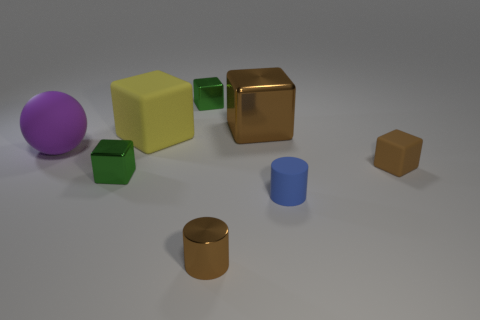Subtract all yellow blocks. How many blocks are left? 4 Subtract all big shiny blocks. How many blocks are left? 4 Subtract all cyan cubes. Subtract all yellow spheres. How many cubes are left? 5 Add 2 blue things. How many objects exist? 10 Subtract all cylinders. How many objects are left? 6 Subtract 0 purple cubes. How many objects are left? 8 Subtract all big shiny objects. Subtract all tiny brown shiny objects. How many objects are left? 6 Add 3 brown rubber blocks. How many brown rubber blocks are left? 4 Add 1 blue matte objects. How many blue matte objects exist? 2 